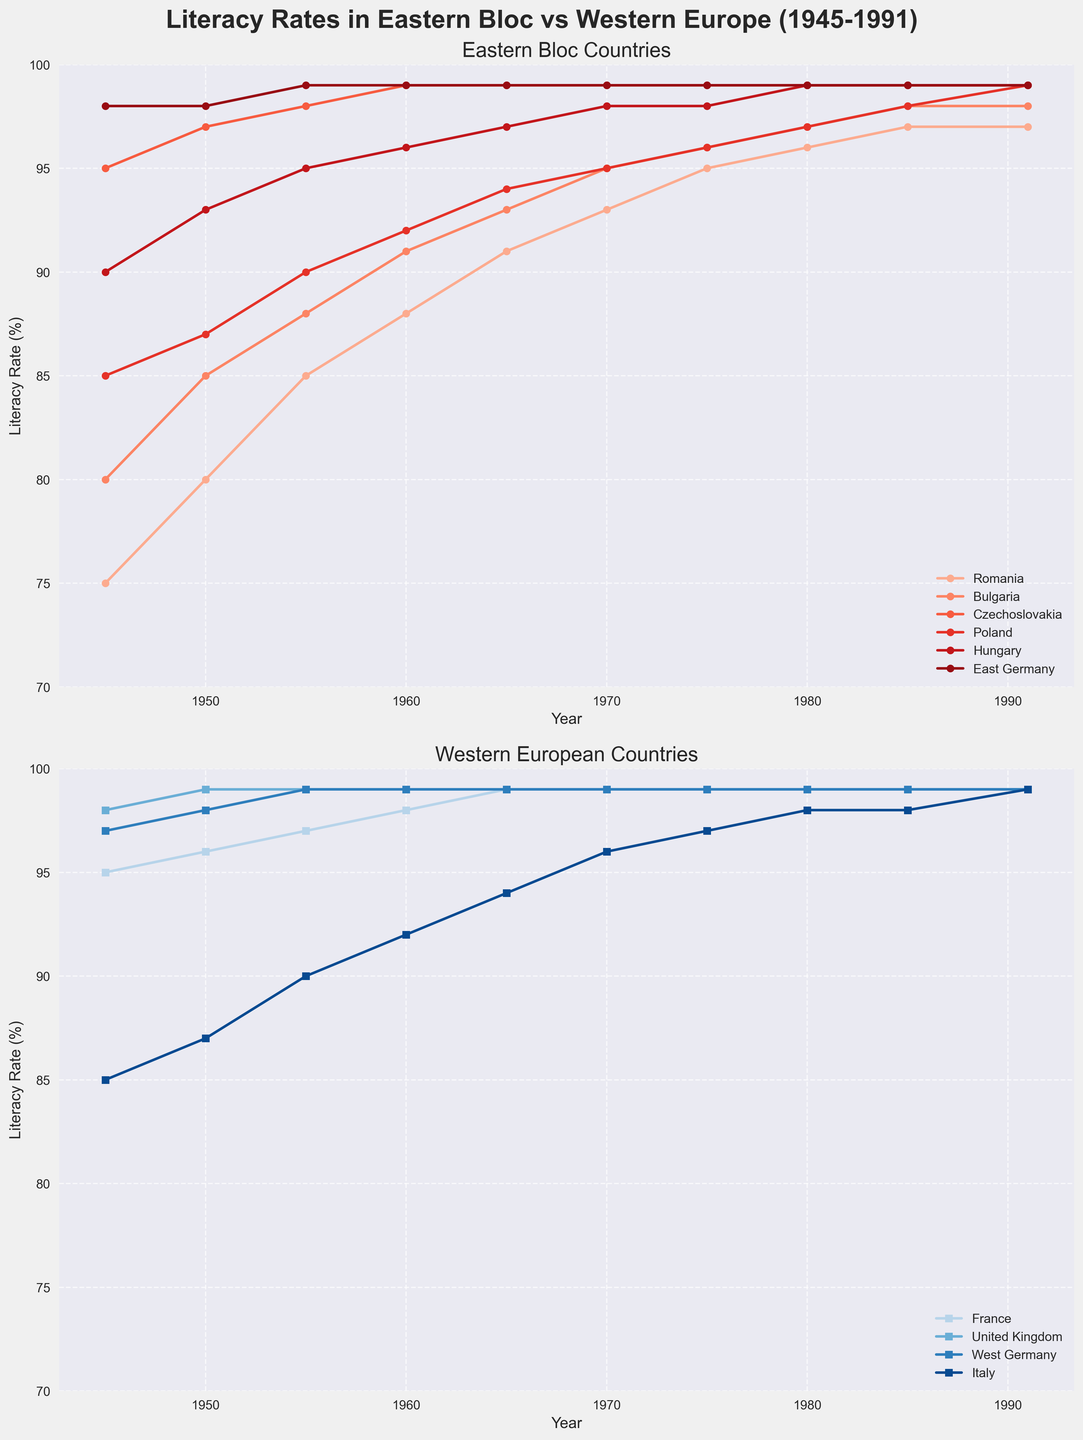What's the lowest literacy rate for Romania throughout the years shown in the plot? The plot shows that the literacy rate for Romania is lowest in 1945. It is represented by the first data point in the solid red line for Romania.
Answer: 75% Which country had the highest literacy rate in the Eastern Bloc in 1945? Observing the top-most point in the Eastern Bloc subplot for 1945, East Germany has a literacy rate of 98%, which is the highest among the Eastern Bloc countries in that year.
Answer: East Germany How did the literacy rate of Poland change from 1945 to 1991? Following the trend of the line representing Poland in the Eastern Bloc subplot, we see the rate increased steadily from 85% in 1945 to 99% in 1991.
Answer: Increased from 85% to 99% Compare the literacy rate of West Germany and East Germany in 1991. The end points of the lines representing West Germany (blue) and East Germany (red) in each subplot provide this information. Both countries have a literacy rate of 99% in 1991.
Answer: Both are 99% In which year did Italy reach a literacy rate of 99%? Tracing the line representing Italy in the Western Europe subplot, Italy reached a literacy rate of 99% in the year 1975.
Answer: 1975 Which country had the slowest growth in literacy rates in Eastern Bloc countries from 1945 to 1991? Observing the slopes of the lines in the Eastern Bloc subplot, Czechoslovakia has a nearly flat line because it started at 95% in 1945 and reached only 99% in 1991, indicating the slowest growth among the others.
Answer: Czechoslovakia Between 1945 and 1950, which Western European country saw the largest increase in literacy rates? Inspecting the lines in the Western Europe subplot for 1945 and 1950, Italy saw the largest increase from 85% to 87%, a 2% increase, which is the largest among the Western countries.
Answer: Italy How does the literacy rate trajectory of Hungary compare to France between 1945 and 1991? By comparing the lines representing Hungary in the Eastern Bloc subplot and France in the Western Europe subplot, both countries increased their literacy rates over time, but Hungary started from a lower rate (90%) and reached the same rate (99%) by 1991, while France started at 95% and reached the same 99%.
Answer: Hungary rose from 90% to 99%, France rose from 95% to 99% What was the difference in literacy rates between Romania and the United Kingdom in 1960? In 1960, the lines show that Romania had a literacy rate of 88%, while the United Kingdom had 99%. The difference is calculated as 99% - 88%.
Answer: 11% Identify the trend of literacy rates in Czechoslovakia from 1945 to 1991. Observing the line for Czechoslovakia in the Eastern Bloc subplot, the country's literacy rate remains nearly constant at 99% after an initial rate of 95% in 1945.
Answer: Nearly constant after 1945 